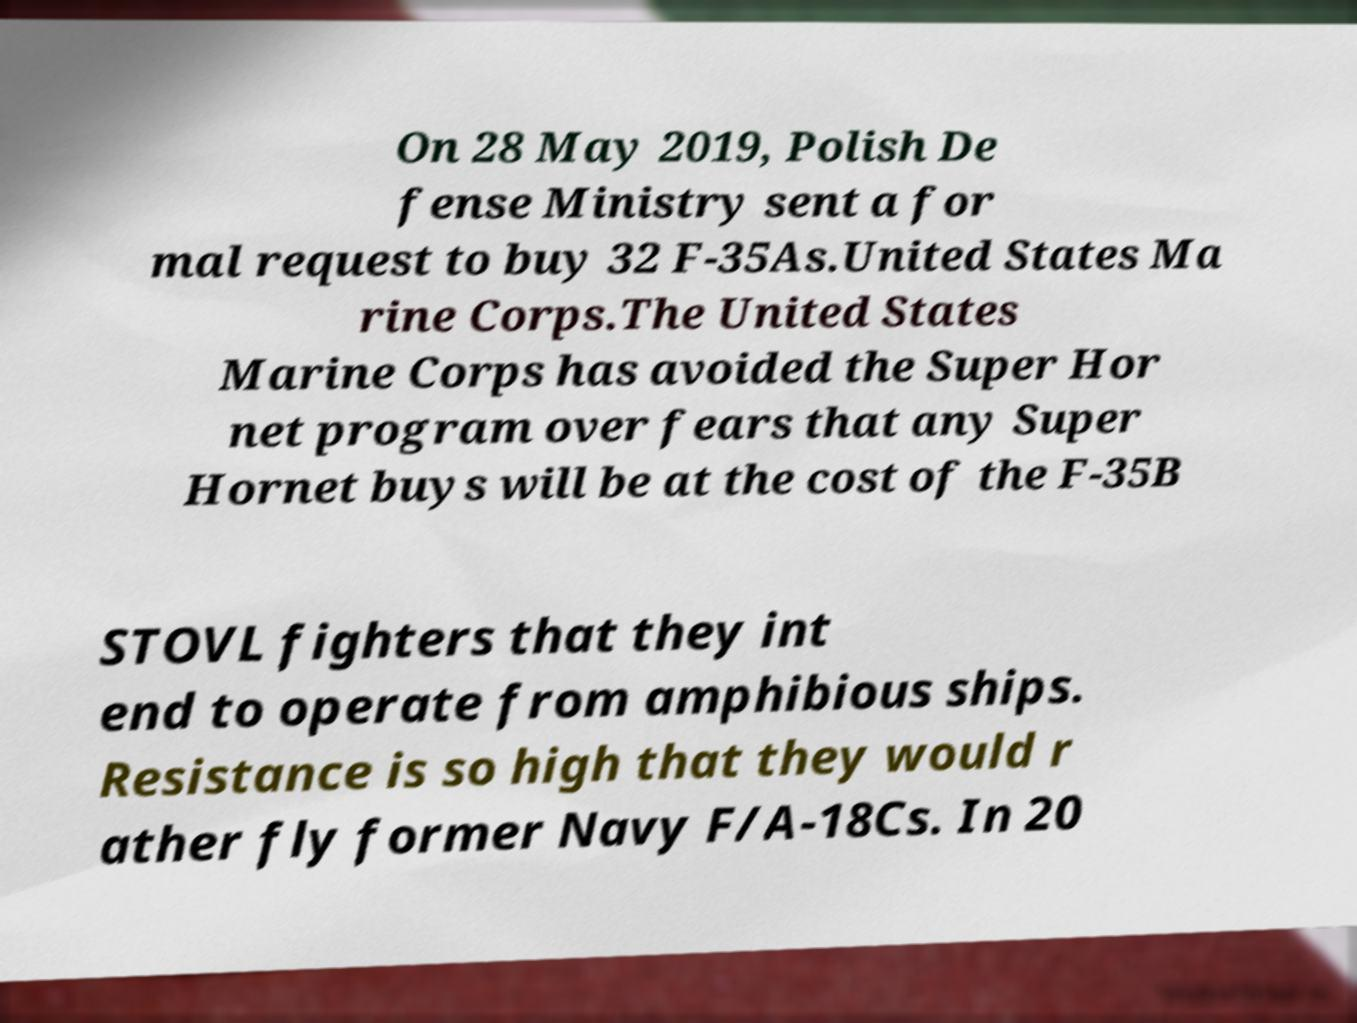Please identify and transcribe the text found in this image. On 28 May 2019, Polish De fense Ministry sent a for mal request to buy 32 F-35As.United States Ma rine Corps.The United States Marine Corps has avoided the Super Hor net program over fears that any Super Hornet buys will be at the cost of the F-35B STOVL fighters that they int end to operate from amphibious ships. Resistance is so high that they would r ather fly former Navy F/A-18Cs. In 20 